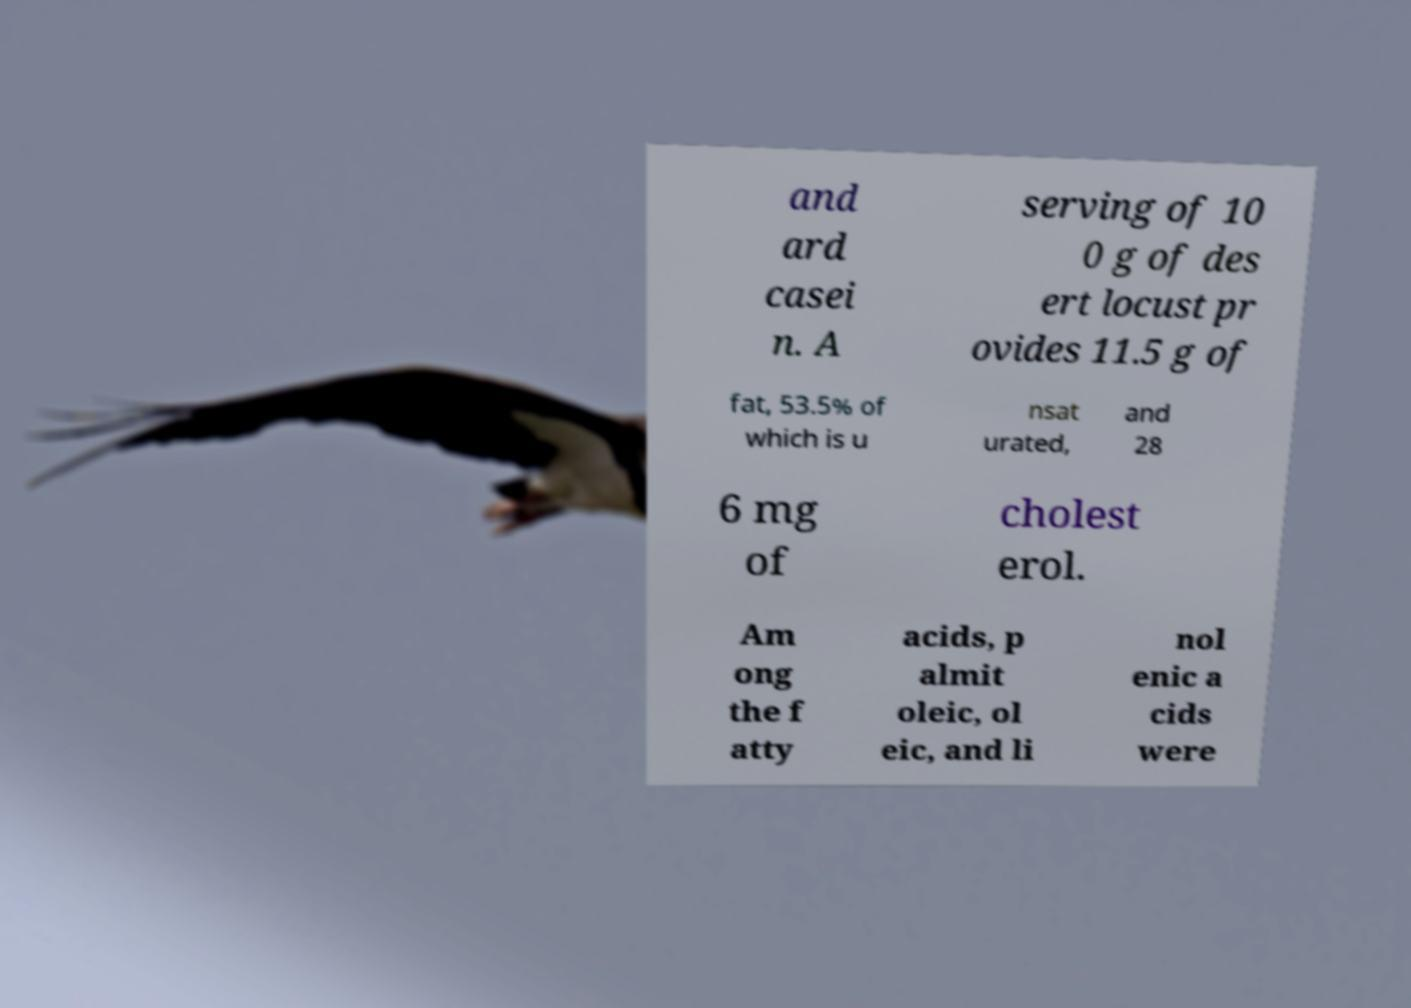I need the written content from this picture converted into text. Can you do that? and ard casei n. A serving of 10 0 g of des ert locust pr ovides 11.5 g of fat, 53.5% of which is u nsat urated, and 28 6 mg of cholest erol. Am ong the f atty acids, p almit oleic, ol eic, and li nol enic a cids were 